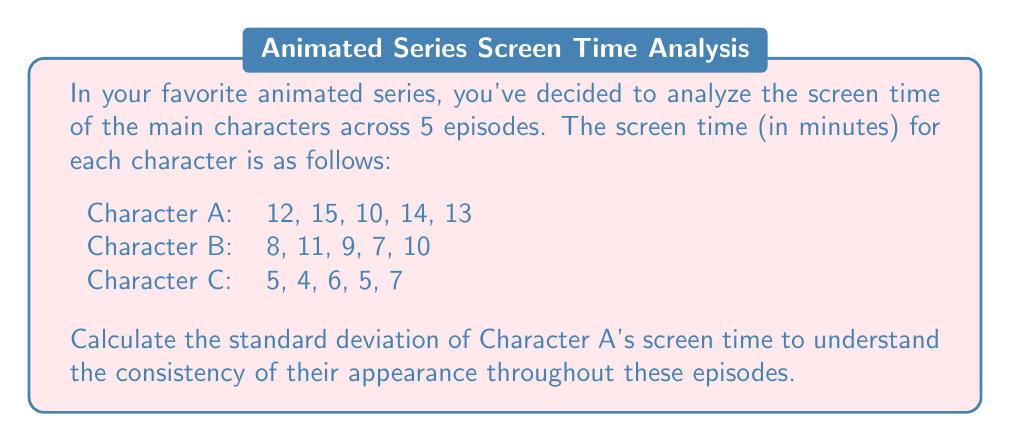Can you answer this question? To calculate the standard deviation, we'll follow these steps:

1. Calculate the mean (average) screen time:
   $$\bar{x} = \frac{12 + 15 + 10 + 14 + 13}{5} = \frac{64}{5} = 12.8$$

2. Calculate the squared differences from the mean:
   $$(12 - 12.8)^2 = (-0.8)^2 = 0.64$$
   $$(15 - 12.8)^2 = (2.2)^2 = 4.84$$
   $$(10 - 12.8)^2 = (-2.8)^2 = 7.84$$
   $$(14 - 12.8)^2 = (1.2)^2 = 1.44$$
   $$(13 - 12.8)^2 = (0.2)^2 = 0.04$$

3. Calculate the average of the squared differences:
   $$\frac{0.64 + 4.84 + 7.84 + 1.44 + 0.04}{5} = \frac{14.8}{5} = 2.96$$

4. Take the square root of the result to get the standard deviation:
   $$\sigma = \sqrt{2.96} \approx 1.72$$
Answer: $1.72$ minutes 